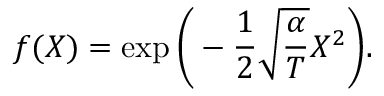<formula> <loc_0><loc_0><loc_500><loc_500>f ( X ) = \exp \left ( - \frac { 1 } { 2 } \sqrt { \frac { \alpha } { T } } X ^ { 2 } \right ) .</formula> 